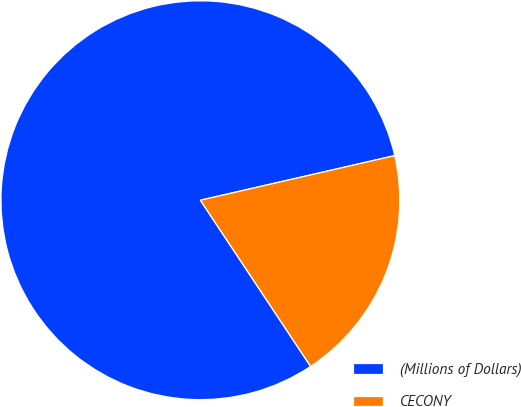Convert chart to OTSL. <chart><loc_0><loc_0><loc_500><loc_500><pie_chart><fcel>(Millions of Dollars)<fcel>CECONY<nl><fcel>80.73%<fcel>19.27%<nl></chart> 